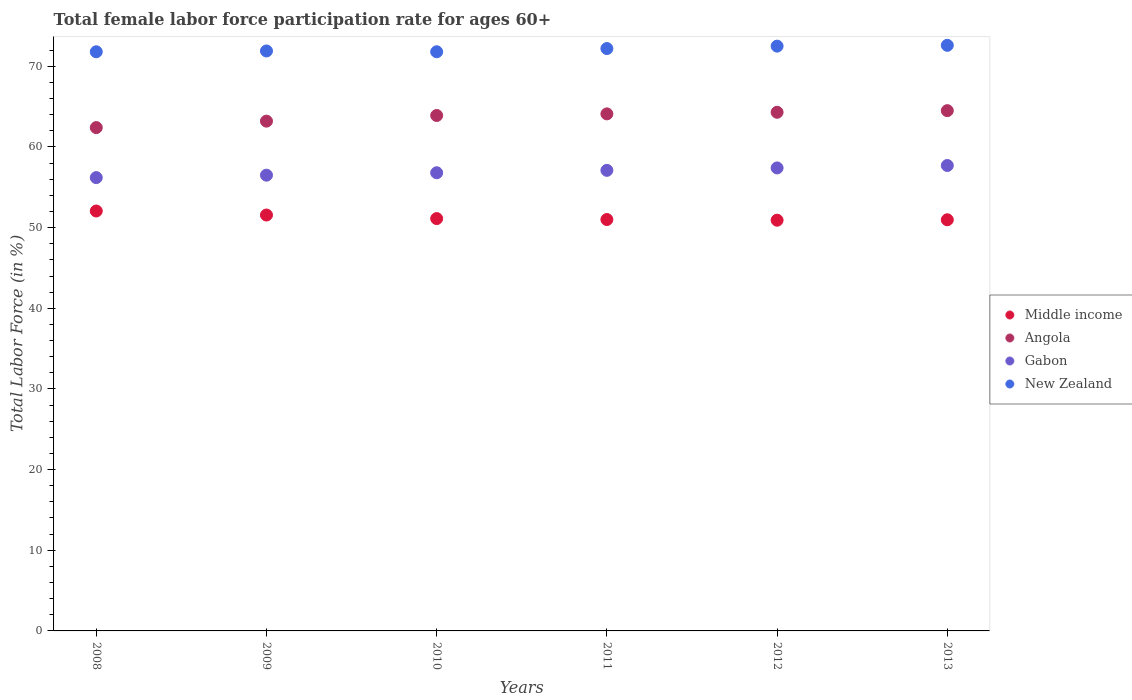How many different coloured dotlines are there?
Your response must be concise. 4. Is the number of dotlines equal to the number of legend labels?
Make the answer very short. Yes. What is the female labor force participation rate in Angola in 2011?
Ensure brevity in your answer.  64.1. Across all years, what is the maximum female labor force participation rate in Angola?
Your answer should be very brief. 64.5. Across all years, what is the minimum female labor force participation rate in Gabon?
Offer a very short reply. 56.2. In which year was the female labor force participation rate in New Zealand maximum?
Make the answer very short. 2013. In which year was the female labor force participation rate in Middle income minimum?
Keep it short and to the point. 2012. What is the total female labor force participation rate in Gabon in the graph?
Your answer should be very brief. 341.7. What is the difference between the female labor force participation rate in Angola in 2009 and that in 2011?
Your answer should be very brief. -0.9. What is the difference between the female labor force participation rate in Middle income in 2011 and the female labor force participation rate in Gabon in 2013?
Ensure brevity in your answer.  -6.7. What is the average female labor force participation rate in Middle income per year?
Offer a very short reply. 51.27. In the year 2009, what is the difference between the female labor force participation rate in Middle income and female labor force participation rate in Angola?
Your answer should be compact. -11.64. What is the ratio of the female labor force participation rate in New Zealand in 2009 to that in 2011?
Your answer should be compact. 1. Is the difference between the female labor force participation rate in Middle income in 2010 and 2011 greater than the difference between the female labor force participation rate in Angola in 2010 and 2011?
Your answer should be very brief. Yes. What is the difference between the highest and the second highest female labor force participation rate in Gabon?
Your answer should be very brief. 0.3. What is the difference between the highest and the lowest female labor force participation rate in Middle income?
Keep it short and to the point. 1.14. In how many years, is the female labor force participation rate in Angola greater than the average female labor force participation rate in Angola taken over all years?
Make the answer very short. 4. Is it the case that in every year, the sum of the female labor force participation rate in Angola and female labor force participation rate in New Zealand  is greater than the female labor force participation rate in Gabon?
Ensure brevity in your answer.  Yes. Is the female labor force participation rate in Angola strictly greater than the female labor force participation rate in Middle income over the years?
Offer a very short reply. Yes. Is the female labor force participation rate in New Zealand strictly less than the female labor force participation rate in Angola over the years?
Give a very brief answer. No. What is the difference between two consecutive major ticks on the Y-axis?
Ensure brevity in your answer.  10. Does the graph contain grids?
Keep it short and to the point. No. How many legend labels are there?
Provide a succinct answer. 4. What is the title of the graph?
Your response must be concise. Total female labor force participation rate for ages 60+. Does "Trinidad and Tobago" appear as one of the legend labels in the graph?
Offer a very short reply. No. What is the label or title of the X-axis?
Ensure brevity in your answer.  Years. What is the Total Labor Force (in %) of Middle income in 2008?
Your response must be concise. 52.06. What is the Total Labor Force (in %) of Angola in 2008?
Your answer should be compact. 62.4. What is the Total Labor Force (in %) of Gabon in 2008?
Your response must be concise. 56.2. What is the Total Labor Force (in %) of New Zealand in 2008?
Offer a very short reply. 71.8. What is the Total Labor Force (in %) of Middle income in 2009?
Provide a short and direct response. 51.56. What is the Total Labor Force (in %) of Angola in 2009?
Your answer should be very brief. 63.2. What is the Total Labor Force (in %) in Gabon in 2009?
Your response must be concise. 56.5. What is the Total Labor Force (in %) of New Zealand in 2009?
Your response must be concise. 71.9. What is the Total Labor Force (in %) of Middle income in 2010?
Offer a very short reply. 51.12. What is the Total Labor Force (in %) in Angola in 2010?
Make the answer very short. 63.9. What is the Total Labor Force (in %) of Gabon in 2010?
Make the answer very short. 56.8. What is the Total Labor Force (in %) in New Zealand in 2010?
Your answer should be compact. 71.8. What is the Total Labor Force (in %) in Middle income in 2011?
Provide a succinct answer. 51. What is the Total Labor Force (in %) of Angola in 2011?
Give a very brief answer. 64.1. What is the Total Labor Force (in %) of Gabon in 2011?
Give a very brief answer. 57.1. What is the Total Labor Force (in %) of New Zealand in 2011?
Your answer should be very brief. 72.2. What is the Total Labor Force (in %) of Middle income in 2012?
Give a very brief answer. 50.92. What is the Total Labor Force (in %) of Angola in 2012?
Provide a short and direct response. 64.3. What is the Total Labor Force (in %) in Gabon in 2012?
Your answer should be compact. 57.4. What is the Total Labor Force (in %) in New Zealand in 2012?
Offer a very short reply. 72.5. What is the Total Labor Force (in %) in Middle income in 2013?
Your answer should be compact. 50.97. What is the Total Labor Force (in %) of Angola in 2013?
Your answer should be very brief. 64.5. What is the Total Labor Force (in %) in Gabon in 2013?
Your answer should be very brief. 57.7. What is the Total Labor Force (in %) in New Zealand in 2013?
Ensure brevity in your answer.  72.6. Across all years, what is the maximum Total Labor Force (in %) of Middle income?
Your response must be concise. 52.06. Across all years, what is the maximum Total Labor Force (in %) in Angola?
Provide a short and direct response. 64.5. Across all years, what is the maximum Total Labor Force (in %) of Gabon?
Keep it short and to the point. 57.7. Across all years, what is the maximum Total Labor Force (in %) of New Zealand?
Provide a succinct answer. 72.6. Across all years, what is the minimum Total Labor Force (in %) in Middle income?
Provide a short and direct response. 50.92. Across all years, what is the minimum Total Labor Force (in %) of Angola?
Offer a terse response. 62.4. Across all years, what is the minimum Total Labor Force (in %) of Gabon?
Provide a short and direct response. 56.2. Across all years, what is the minimum Total Labor Force (in %) in New Zealand?
Your answer should be compact. 71.8. What is the total Total Labor Force (in %) of Middle income in the graph?
Your response must be concise. 307.63. What is the total Total Labor Force (in %) in Angola in the graph?
Give a very brief answer. 382.4. What is the total Total Labor Force (in %) of Gabon in the graph?
Give a very brief answer. 341.7. What is the total Total Labor Force (in %) of New Zealand in the graph?
Make the answer very short. 432.8. What is the difference between the Total Labor Force (in %) of Middle income in 2008 and that in 2009?
Keep it short and to the point. 0.5. What is the difference between the Total Labor Force (in %) of Angola in 2008 and that in 2009?
Offer a terse response. -0.8. What is the difference between the Total Labor Force (in %) of Gabon in 2008 and that in 2009?
Your response must be concise. -0.3. What is the difference between the Total Labor Force (in %) of Middle income in 2008 and that in 2010?
Your answer should be very brief. 0.94. What is the difference between the Total Labor Force (in %) of Middle income in 2008 and that in 2011?
Provide a succinct answer. 1.06. What is the difference between the Total Labor Force (in %) in Angola in 2008 and that in 2011?
Keep it short and to the point. -1.7. What is the difference between the Total Labor Force (in %) of Gabon in 2008 and that in 2011?
Your response must be concise. -0.9. What is the difference between the Total Labor Force (in %) of New Zealand in 2008 and that in 2011?
Your answer should be compact. -0.4. What is the difference between the Total Labor Force (in %) in Middle income in 2008 and that in 2012?
Provide a short and direct response. 1.14. What is the difference between the Total Labor Force (in %) of Middle income in 2008 and that in 2013?
Give a very brief answer. 1.09. What is the difference between the Total Labor Force (in %) of Angola in 2008 and that in 2013?
Your answer should be compact. -2.1. What is the difference between the Total Labor Force (in %) of Gabon in 2008 and that in 2013?
Your answer should be compact. -1.5. What is the difference between the Total Labor Force (in %) in New Zealand in 2008 and that in 2013?
Offer a terse response. -0.8. What is the difference between the Total Labor Force (in %) of Middle income in 2009 and that in 2010?
Your response must be concise. 0.44. What is the difference between the Total Labor Force (in %) in Angola in 2009 and that in 2010?
Your response must be concise. -0.7. What is the difference between the Total Labor Force (in %) of Middle income in 2009 and that in 2011?
Your answer should be very brief. 0.56. What is the difference between the Total Labor Force (in %) of Middle income in 2009 and that in 2012?
Your response must be concise. 0.64. What is the difference between the Total Labor Force (in %) of New Zealand in 2009 and that in 2012?
Offer a terse response. -0.6. What is the difference between the Total Labor Force (in %) in Middle income in 2009 and that in 2013?
Ensure brevity in your answer.  0.59. What is the difference between the Total Labor Force (in %) of Angola in 2009 and that in 2013?
Your response must be concise. -1.3. What is the difference between the Total Labor Force (in %) in Gabon in 2009 and that in 2013?
Ensure brevity in your answer.  -1.2. What is the difference between the Total Labor Force (in %) of Middle income in 2010 and that in 2011?
Offer a very short reply. 0.12. What is the difference between the Total Labor Force (in %) of Angola in 2010 and that in 2011?
Offer a terse response. -0.2. What is the difference between the Total Labor Force (in %) of Middle income in 2010 and that in 2012?
Your answer should be very brief. 0.2. What is the difference between the Total Labor Force (in %) in Angola in 2010 and that in 2012?
Provide a short and direct response. -0.4. What is the difference between the Total Labor Force (in %) in Middle income in 2010 and that in 2013?
Your answer should be compact. 0.15. What is the difference between the Total Labor Force (in %) of Middle income in 2011 and that in 2012?
Provide a short and direct response. 0.08. What is the difference between the Total Labor Force (in %) in Angola in 2011 and that in 2012?
Ensure brevity in your answer.  -0.2. What is the difference between the Total Labor Force (in %) of New Zealand in 2011 and that in 2012?
Provide a succinct answer. -0.3. What is the difference between the Total Labor Force (in %) in Middle income in 2011 and that in 2013?
Your answer should be compact. 0.03. What is the difference between the Total Labor Force (in %) in Angola in 2011 and that in 2013?
Make the answer very short. -0.4. What is the difference between the Total Labor Force (in %) in New Zealand in 2011 and that in 2013?
Give a very brief answer. -0.4. What is the difference between the Total Labor Force (in %) of Middle income in 2012 and that in 2013?
Offer a very short reply. -0.05. What is the difference between the Total Labor Force (in %) in Gabon in 2012 and that in 2013?
Make the answer very short. -0.3. What is the difference between the Total Labor Force (in %) of New Zealand in 2012 and that in 2013?
Make the answer very short. -0.1. What is the difference between the Total Labor Force (in %) in Middle income in 2008 and the Total Labor Force (in %) in Angola in 2009?
Give a very brief answer. -11.14. What is the difference between the Total Labor Force (in %) in Middle income in 2008 and the Total Labor Force (in %) in Gabon in 2009?
Keep it short and to the point. -4.44. What is the difference between the Total Labor Force (in %) of Middle income in 2008 and the Total Labor Force (in %) of New Zealand in 2009?
Provide a succinct answer. -19.84. What is the difference between the Total Labor Force (in %) of Angola in 2008 and the Total Labor Force (in %) of Gabon in 2009?
Your answer should be compact. 5.9. What is the difference between the Total Labor Force (in %) in Angola in 2008 and the Total Labor Force (in %) in New Zealand in 2009?
Make the answer very short. -9.5. What is the difference between the Total Labor Force (in %) of Gabon in 2008 and the Total Labor Force (in %) of New Zealand in 2009?
Your answer should be very brief. -15.7. What is the difference between the Total Labor Force (in %) of Middle income in 2008 and the Total Labor Force (in %) of Angola in 2010?
Your answer should be compact. -11.84. What is the difference between the Total Labor Force (in %) of Middle income in 2008 and the Total Labor Force (in %) of Gabon in 2010?
Keep it short and to the point. -4.74. What is the difference between the Total Labor Force (in %) of Middle income in 2008 and the Total Labor Force (in %) of New Zealand in 2010?
Your response must be concise. -19.74. What is the difference between the Total Labor Force (in %) in Gabon in 2008 and the Total Labor Force (in %) in New Zealand in 2010?
Ensure brevity in your answer.  -15.6. What is the difference between the Total Labor Force (in %) of Middle income in 2008 and the Total Labor Force (in %) of Angola in 2011?
Your answer should be very brief. -12.04. What is the difference between the Total Labor Force (in %) of Middle income in 2008 and the Total Labor Force (in %) of Gabon in 2011?
Provide a short and direct response. -5.04. What is the difference between the Total Labor Force (in %) in Middle income in 2008 and the Total Labor Force (in %) in New Zealand in 2011?
Ensure brevity in your answer.  -20.14. What is the difference between the Total Labor Force (in %) in Angola in 2008 and the Total Labor Force (in %) in Gabon in 2011?
Provide a short and direct response. 5.3. What is the difference between the Total Labor Force (in %) of Angola in 2008 and the Total Labor Force (in %) of New Zealand in 2011?
Provide a succinct answer. -9.8. What is the difference between the Total Labor Force (in %) in Gabon in 2008 and the Total Labor Force (in %) in New Zealand in 2011?
Offer a terse response. -16. What is the difference between the Total Labor Force (in %) of Middle income in 2008 and the Total Labor Force (in %) of Angola in 2012?
Provide a short and direct response. -12.24. What is the difference between the Total Labor Force (in %) in Middle income in 2008 and the Total Labor Force (in %) in Gabon in 2012?
Keep it short and to the point. -5.34. What is the difference between the Total Labor Force (in %) of Middle income in 2008 and the Total Labor Force (in %) of New Zealand in 2012?
Offer a very short reply. -20.44. What is the difference between the Total Labor Force (in %) in Angola in 2008 and the Total Labor Force (in %) in New Zealand in 2012?
Your answer should be compact. -10.1. What is the difference between the Total Labor Force (in %) of Gabon in 2008 and the Total Labor Force (in %) of New Zealand in 2012?
Ensure brevity in your answer.  -16.3. What is the difference between the Total Labor Force (in %) of Middle income in 2008 and the Total Labor Force (in %) of Angola in 2013?
Keep it short and to the point. -12.44. What is the difference between the Total Labor Force (in %) in Middle income in 2008 and the Total Labor Force (in %) in Gabon in 2013?
Your answer should be very brief. -5.64. What is the difference between the Total Labor Force (in %) of Middle income in 2008 and the Total Labor Force (in %) of New Zealand in 2013?
Make the answer very short. -20.54. What is the difference between the Total Labor Force (in %) in Angola in 2008 and the Total Labor Force (in %) in New Zealand in 2013?
Your answer should be very brief. -10.2. What is the difference between the Total Labor Force (in %) in Gabon in 2008 and the Total Labor Force (in %) in New Zealand in 2013?
Offer a terse response. -16.4. What is the difference between the Total Labor Force (in %) in Middle income in 2009 and the Total Labor Force (in %) in Angola in 2010?
Give a very brief answer. -12.34. What is the difference between the Total Labor Force (in %) of Middle income in 2009 and the Total Labor Force (in %) of Gabon in 2010?
Offer a terse response. -5.24. What is the difference between the Total Labor Force (in %) of Middle income in 2009 and the Total Labor Force (in %) of New Zealand in 2010?
Keep it short and to the point. -20.24. What is the difference between the Total Labor Force (in %) in Angola in 2009 and the Total Labor Force (in %) in New Zealand in 2010?
Offer a terse response. -8.6. What is the difference between the Total Labor Force (in %) of Gabon in 2009 and the Total Labor Force (in %) of New Zealand in 2010?
Offer a terse response. -15.3. What is the difference between the Total Labor Force (in %) of Middle income in 2009 and the Total Labor Force (in %) of Angola in 2011?
Your answer should be very brief. -12.54. What is the difference between the Total Labor Force (in %) in Middle income in 2009 and the Total Labor Force (in %) in Gabon in 2011?
Your answer should be very brief. -5.54. What is the difference between the Total Labor Force (in %) in Middle income in 2009 and the Total Labor Force (in %) in New Zealand in 2011?
Provide a short and direct response. -20.64. What is the difference between the Total Labor Force (in %) in Angola in 2009 and the Total Labor Force (in %) in Gabon in 2011?
Provide a short and direct response. 6.1. What is the difference between the Total Labor Force (in %) of Gabon in 2009 and the Total Labor Force (in %) of New Zealand in 2011?
Ensure brevity in your answer.  -15.7. What is the difference between the Total Labor Force (in %) of Middle income in 2009 and the Total Labor Force (in %) of Angola in 2012?
Your response must be concise. -12.74. What is the difference between the Total Labor Force (in %) in Middle income in 2009 and the Total Labor Force (in %) in Gabon in 2012?
Offer a very short reply. -5.84. What is the difference between the Total Labor Force (in %) in Middle income in 2009 and the Total Labor Force (in %) in New Zealand in 2012?
Offer a very short reply. -20.94. What is the difference between the Total Labor Force (in %) in Gabon in 2009 and the Total Labor Force (in %) in New Zealand in 2012?
Keep it short and to the point. -16. What is the difference between the Total Labor Force (in %) in Middle income in 2009 and the Total Labor Force (in %) in Angola in 2013?
Provide a succinct answer. -12.94. What is the difference between the Total Labor Force (in %) of Middle income in 2009 and the Total Labor Force (in %) of Gabon in 2013?
Provide a short and direct response. -6.14. What is the difference between the Total Labor Force (in %) of Middle income in 2009 and the Total Labor Force (in %) of New Zealand in 2013?
Your response must be concise. -21.04. What is the difference between the Total Labor Force (in %) of Angola in 2009 and the Total Labor Force (in %) of Gabon in 2013?
Ensure brevity in your answer.  5.5. What is the difference between the Total Labor Force (in %) in Angola in 2009 and the Total Labor Force (in %) in New Zealand in 2013?
Keep it short and to the point. -9.4. What is the difference between the Total Labor Force (in %) of Gabon in 2009 and the Total Labor Force (in %) of New Zealand in 2013?
Give a very brief answer. -16.1. What is the difference between the Total Labor Force (in %) in Middle income in 2010 and the Total Labor Force (in %) in Angola in 2011?
Your answer should be very brief. -12.98. What is the difference between the Total Labor Force (in %) in Middle income in 2010 and the Total Labor Force (in %) in Gabon in 2011?
Provide a short and direct response. -5.98. What is the difference between the Total Labor Force (in %) in Middle income in 2010 and the Total Labor Force (in %) in New Zealand in 2011?
Offer a terse response. -21.08. What is the difference between the Total Labor Force (in %) of Gabon in 2010 and the Total Labor Force (in %) of New Zealand in 2011?
Make the answer very short. -15.4. What is the difference between the Total Labor Force (in %) of Middle income in 2010 and the Total Labor Force (in %) of Angola in 2012?
Your response must be concise. -13.18. What is the difference between the Total Labor Force (in %) of Middle income in 2010 and the Total Labor Force (in %) of Gabon in 2012?
Keep it short and to the point. -6.28. What is the difference between the Total Labor Force (in %) in Middle income in 2010 and the Total Labor Force (in %) in New Zealand in 2012?
Keep it short and to the point. -21.38. What is the difference between the Total Labor Force (in %) in Angola in 2010 and the Total Labor Force (in %) in Gabon in 2012?
Your answer should be very brief. 6.5. What is the difference between the Total Labor Force (in %) in Angola in 2010 and the Total Labor Force (in %) in New Zealand in 2012?
Make the answer very short. -8.6. What is the difference between the Total Labor Force (in %) of Gabon in 2010 and the Total Labor Force (in %) of New Zealand in 2012?
Keep it short and to the point. -15.7. What is the difference between the Total Labor Force (in %) in Middle income in 2010 and the Total Labor Force (in %) in Angola in 2013?
Give a very brief answer. -13.38. What is the difference between the Total Labor Force (in %) in Middle income in 2010 and the Total Labor Force (in %) in Gabon in 2013?
Provide a short and direct response. -6.58. What is the difference between the Total Labor Force (in %) in Middle income in 2010 and the Total Labor Force (in %) in New Zealand in 2013?
Provide a succinct answer. -21.48. What is the difference between the Total Labor Force (in %) of Angola in 2010 and the Total Labor Force (in %) of New Zealand in 2013?
Ensure brevity in your answer.  -8.7. What is the difference between the Total Labor Force (in %) in Gabon in 2010 and the Total Labor Force (in %) in New Zealand in 2013?
Offer a very short reply. -15.8. What is the difference between the Total Labor Force (in %) of Middle income in 2011 and the Total Labor Force (in %) of Angola in 2012?
Ensure brevity in your answer.  -13.3. What is the difference between the Total Labor Force (in %) in Middle income in 2011 and the Total Labor Force (in %) in Gabon in 2012?
Your answer should be very brief. -6.4. What is the difference between the Total Labor Force (in %) of Middle income in 2011 and the Total Labor Force (in %) of New Zealand in 2012?
Your answer should be compact. -21.5. What is the difference between the Total Labor Force (in %) of Angola in 2011 and the Total Labor Force (in %) of Gabon in 2012?
Your answer should be compact. 6.7. What is the difference between the Total Labor Force (in %) in Gabon in 2011 and the Total Labor Force (in %) in New Zealand in 2012?
Your response must be concise. -15.4. What is the difference between the Total Labor Force (in %) of Middle income in 2011 and the Total Labor Force (in %) of Angola in 2013?
Your answer should be very brief. -13.5. What is the difference between the Total Labor Force (in %) in Middle income in 2011 and the Total Labor Force (in %) in Gabon in 2013?
Ensure brevity in your answer.  -6.7. What is the difference between the Total Labor Force (in %) of Middle income in 2011 and the Total Labor Force (in %) of New Zealand in 2013?
Ensure brevity in your answer.  -21.6. What is the difference between the Total Labor Force (in %) in Gabon in 2011 and the Total Labor Force (in %) in New Zealand in 2013?
Offer a terse response. -15.5. What is the difference between the Total Labor Force (in %) in Middle income in 2012 and the Total Labor Force (in %) in Angola in 2013?
Your response must be concise. -13.58. What is the difference between the Total Labor Force (in %) of Middle income in 2012 and the Total Labor Force (in %) of Gabon in 2013?
Your response must be concise. -6.78. What is the difference between the Total Labor Force (in %) of Middle income in 2012 and the Total Labor Force (in %) of New Zealand in 2013?
Provide a short and direct response. -21.68. What is the difference between the Total Labor Force (in %) in Gabon in 2012 and the Total Labor Force (in %) in New Zealand in 2013?
Provide a succinct answer. -15.2. What is the average Total Labor Force (in %) of Middle income per year?
Provide a short and direct response. 51.27. What is the average Total Labor Force (in %) in Angola per year?
Your answer should be very brief. 63.73. What is the average Total Labor Force (in %) of Gabon per year?
Ensure brevity in your answer.  56.95. What is the average Total Labor Force (in %) in New Zealand per year?
Offer a very short reply. 72.13. In the year 2008, what is the difference between the Total Labor Force (in %) in Middle income and Total Labor Force (in %) in Angola?
Your answer should be very brief. -10.34. In the year 2008, what is the difference between the Total Labor Force (in %) in Middle income and Total Labor Force (in %) in Gabon?
Make the answer very short. -4.14. In the year 2008, what is the difference between the Total Labor Force (in %) in Middle income and Total Labor Force (in %) in New Zealand?
Give a very brief answer. -19.74. In the year 2008, what is the difference between the Total Labor Force (in %) of Angola and Total Labor Force (in %) of Gabon?
Offer a very short reply. 6.2. In the year 2008, what is the difference between the Total Labor Force (in %) of Angola and Total Labor Force (in %) of New Zealand?
Provide a short and direct response. -9.4. In the year 2008, what is the difference between the Total Labor Force (in %) of Gabon and Total Labor Force (in %) of New Zealand?
Your response must be concise. -15.6. In the year 2009, what is the difference between the Total Labor Force (in %) in Middle income and Total Labor Force (in %) in Angola?
Your answer should be compact. -11.64. In the year 2009, what is the difference between the Total Labor Force (in %) in Middle income and Total Labor Force (in %) in Gabon?
Your response must be concise. -4.94. In the year 2009, what is the difference between the Total Labor Force (in %) of Middle income and Total Labor Force (in %) of New Zealand?
Give a very brief answer. -20.34. In the year 2009, what is the difference between the Total Labor Force (in %) of Angola and Total Labor Force (in %) of New Zealand?
Offer a very short reply. -8.7. In the year 2009, what is the difference between the Total Labor Force (in %) of Gabon and Total Labor Force (in %) of New Zealand?
Keep it short and to the point. -15.4. In the year 2010, what is the difference between the Total Labor Force (in %) in Middle income and Total Labor Force (in %) in Angola?
Give a very brief answer. -12.78. In the year 2010, what is the difference between the Total Labor Force (in %) of Middle income and Total Labor Force (in %) of Gabon?
Give a very brief answer. -5.68. In the year 2010, what is the difference between the Total Labor Force (in %) in Middle income and Total Labor Force (in %) in New Zealand?
Provide a short and direct response. -20.68. In the year 2010, what is the difference between the Total Labor Force (in %) in Angola and Total Labor Force (in %) in Gabon?
Offer a very short reply. 7.1. In the year 2011, what is the difference between the Total Labor Force (in %) in Middle income and Total Labor Force (in %) in Angola?
Keep it short and to the point. -13.1. In the year 2011, what is the difference between the Total Labor Force (in %) in Middle income and Total Labor Force (in %) in Gabon?
Keep it short and to the point. -6.1. In the year 2011, what is the difference between the Total Labor Force (in %) of Middle income and Total Labor Force (in %) of New Zealand?
Give a very brief answer. -21.2. In the year 2011, what is the difference between the Total Labor Force (in %) of Gabon and Total Labor Force (in %) of New Zealand?
Provide a short and direct response. -15.1. In the year 2012, what is the difference between the Total Labor Force (in %) in Middle income and Total Labor Force (in %) in Angola?
Provide a short and direct response. -13.38. In the year 2012, what is the difference between the Total Labor Force (in %) of Middle income and Total Labor Force (in %) of Gabon?
Offer a terse response. -6.48. In the year 2012, what is the difference between the Total Labor Force (in %) of Middle income and Total Labor Force (in %) of New Zealand?
Keep it short and to the point. -21.58. In the year 2012, what is the difference between the Total Labor Force (in %) of Angola and Total Labor Force (in %) of Gabon?
Your answer should be compact. 6.9. In the year 2012, what is the difference between the Total Labor Force (in %) of Gabon and Total Labor Force (in %) of New Zealand?
Keep it short and to the point. -15.1. In the year 2013, what is the difference between the Total Labor Force (in %) of Middle income and Total Labor Force (in %) of Angola?
Your answer should be very brief. -13.53. In the year 2013, what is the difference between the Total Labor Force (in %) in Middle income and Total Labor Force (in %) in Gabon?
Keep it short and to the point. -6.73. In the year 2013, what is the difference between the Total Labor Force (in %) in Middle income and Total Labor Force (in %) in New Zealand?
Offer a very short reply. -21.63. In the year 2013, what is the difference between the Total Labor Force (in %) of Gabon and Total Labor Force (in %) of New Zealand?
Make the answer very short. -14.9. What is the ratio of the Total Labor Force (in %) in Middle income in 2008 to that in 2009?
Offer a very short reply. 1.01. What is the ratio of the Total Labor Force (in %) in Angola in 2008 to that in 2009?
Make the answer very short. 0.99. What is the ratio of the Total Labor Force (in %) of Gabon in 2008 to that in 2009?
Offer a terse response. 0.99. What is the ratio of the Total Labor Force (in %) of Middle income in 2008 to that in 2010?
Offer a terse response. 1.02. What is the ratio of the Total Labor Force (in %) in Angola in 2008 to that in 2010?
Keep it short and to the point. 0.98. What is the ratio of the Total Labor Force (in %) of Gabon in 2008 to that in 2010?
Offer a very short reply. 0.99. What is the ratio of the Total Labor Force (in %) in New Zealand in 2008 to that in 2010?
Make the answer very short. 1. What is the ratio of the Total Labor Force (in %) of Middle income in 2008 to that in 2011?
Offer a very short reply. 1.02. What is the ratio of the Total Labor Force (in %) of Angola in 2008 to that in 2011?
Offer a terse response. 0.97. What is the ratio of the Total Labor Force (in %) in Gabon in 2008 to that in 2011?
Your answer should be compact. 0.98. What is the ratio of the Total Labor Force (in %) in New Zealand in 2008 to that in 2011?
Your response must be concise. 0.99. What is the ratio of the Total Labor Force (in %) of Middle income in 2008 to that in 2012?
Keep it short and to the point. 1.02. What is the ratio of the Total Labor Force (in %) in Angola in 2008 to that in 2012?
Your answer should be compact. 0.97. What is the ratio of the Total Labor Force (in %) in Gabon in 2008 to that in 2012?
Give a very brief answer. 0.98. What is the ratio of the Total Labor Force (in %) of New Zealand in 2008 to that in 2012?
Provide a short and direct response. 0.99. What is the ratio of the Total Labor Force (in %) in Middle income in 2008 to that in 2013?
Keep it short and to the point. 1.02. What is the ratio of the Total Labor Force (in %) of Angola in 2008 to that in 2013?
Make the answer very short. 0.97. What is the ratio of the Total Labor Force (in %) of Gabon in 2008 to that in 2013?
Your answer should be very brief. 0.97. What is the ratio of the Total Labor Force (in %) in New Zealand in 2008 to that in 2013?
Offer a very short reply. 0.99. What is the ratio of the Total Labor Force (in %) of Middle income in 2009 to that in 2010?
Offer a very short reply. 1.01. What is the ratio of the Total Labor Force (in %) of Angola in 2009 to that in 2010?
Offer a very short reply. 0.99. What is the ratio of the Total Labor Force (in %) of Middle income in 2009 to that in 2011?
Provide a succinct answer. 1.01. What is the ratio of the Total Labor Force (in %) of New Zealand in 2009 to that in 2011?
Your answer should be compact. 1. What is the ratio of the Total Labor Force (in %) of Middle income in 2009 to that in 2012?
Offer a terse response. 1.01. What is the ratio of the Total Labor Force (in %) in Angola in 2009 to that in 2012?
Your answer should be compact. 0.98. What is the ratio of the Total Labor Force (in %) of Gabon in 2009 to that in 2012?
Offer a terse response. 0.98. What is the ratio of the Total Labor Force (in %) of Middle income in 2009 to that in 2013?
Your answer should be compact. 1.01. What is the ratio of the Total Labor Force (in %) in Angola in 2009 to that in 2013?
Offer a terse response. 0.98. What is the ratio of the Total Labor Force (in %) in Gabon in 2009 to that in 2013?
Keep it short and to the point. 0.98. What is the ratio of the Total Labor Force (in %) in Middle income in 2010 to that in 2011?
Offer a terse response. 1. What is the ratio of the Total Labor Force (in %) in Angola in 2010 to that in 2011?
Your answer should be compact. 1. What is the ratio of the Total Labor Force (in %) in Gabon in 2010 to that in 2011?
Offer a terse response. 0.99. What is the ratio of the Total Labor Force (in %) of Middle income in 2010 to that in 2012?
Provide a succinct answer. 1. What is the ratio of the Total Labor Force (in %) of Angola in 2010 to that in 2012?
Give a very brief answer. 0.99. What is the ratio of the Total Labor Force (in %) of New Zealand in 2010 to that in 2012?
Offer a terse response. 0.99. What is the ratio of the Total Labor Force (in %) in Middle income in 2010 to that in 2013?
Keep it short and to the point. 1. What is the ratio of the Total Labor Force (in %) in Angola in 2010 to that in 2013?
Offer a terse response. 0.99. What is the ratio of the Total Labor Force (in %) in Gabon in 2010 to that in 2013?
Your answer should be very brief. 0.98. What is the ratio of the Total Labor Force (in %) in New Zealand in 2010 to that in 2013?
Keep it short and to the point. 0.99. What is the ratio of the Total Labor Force (in %) of Angola in 2011 to that in 2012?
Offer a terse response. 1. What is the ratio of the Total Labor Force (in %) of Middle income in 2011 to that in 2013?
Make the answer very short. 1. What is the ratio of the Total Labor Force (in %) of New Zealand in 2011 to that in 2013?
Give a very brief answer. 0.99. What is the ratio of the Total Labor Force (in %) in Middle income in 2012 to that in 2013?
Provide a succinct answer. 1. What is the difference between the highest and the second highest Total Labor Force (in %) in Middle income?
Keep it short and to the point. 0.5. What is the difference between the highest and the lowest Total Labor Force (in %) in Middle income?
Offer a terse response. 1.14. What is the difference between the highest and the lowest Total Labor Force (in %) of Angola?
Your answer should be compact. 2.1. What is the difference between the highest and the lowest Total Labor Force (in %) of New Zealand?
Your response must be concise. 0.8. 